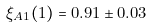Convert formula to latex. <formula><loc_0><loc_0><loc_500><loc_500>\xi _ { A 1 } ( 1 ) = 0 . 9 1 \pm 0 . 0 3</formula> 